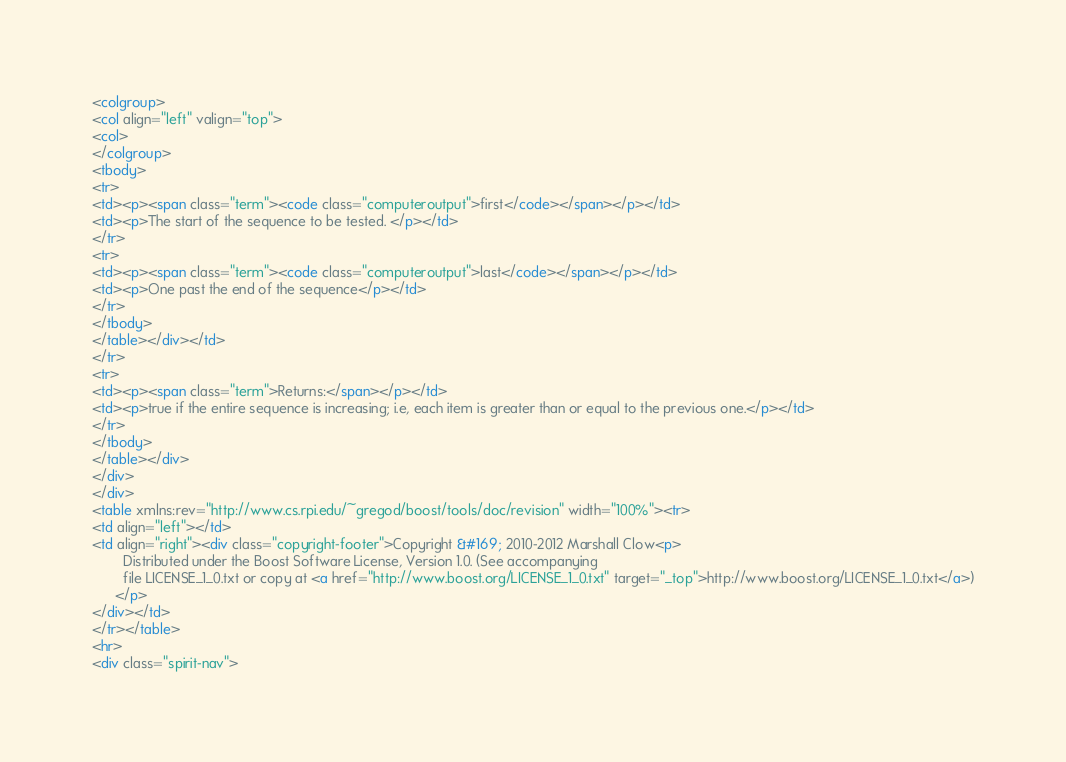Convert code to text. <code><loc_0><loc_0><loc_500><loc_500><_HTML_><colgroup>
<col align="left" valign="top">
<col>
</colgroup>
<tbody>
<tr>
<td><p><span class="term"><code class="computeroutput">first</code></span></p></td>
<td><p>The start of the sequence to be tested. </p></td>
</tr>
<tr>
<td><p><span class="term"><code class="computeroutput">last</code></span></p></td>
<td><p>One past the end of the sequence</p></td>
</tr>
</tbody>
</table></div></td>
</tr>
<tr>
<td><p><span class="term">Returns:</span></p></td>
<td><p>true if the entire sequence is increasing; i.e, each item is greater than or equal to the previous one.</p></td>
</tr>
</tbody>
</table></div>
</div>
</div>
<table xmlns:rev="http://www.cs.rpi.edu/~gregod/boost/tools/doc/revision" width="100%"><tr>
<td align="left"></td>
<td align="right"><div class="copyright-footer">Copyright &#169; 2010-2012 Marshall Clow<p>
        Distributed under the Boost Software License, Version 1.0. (See accompanying
        file LICENSE_1_0.txt or copy at <a href="http://www.boost.org/LICENSE_1_0.txt" target="_top">http://www.boost.org/LICENSE_1_0.txt</a>)
      </p>
</div></td>
</tr></table>
<hr>
<div class="spirit-nav"></code> 